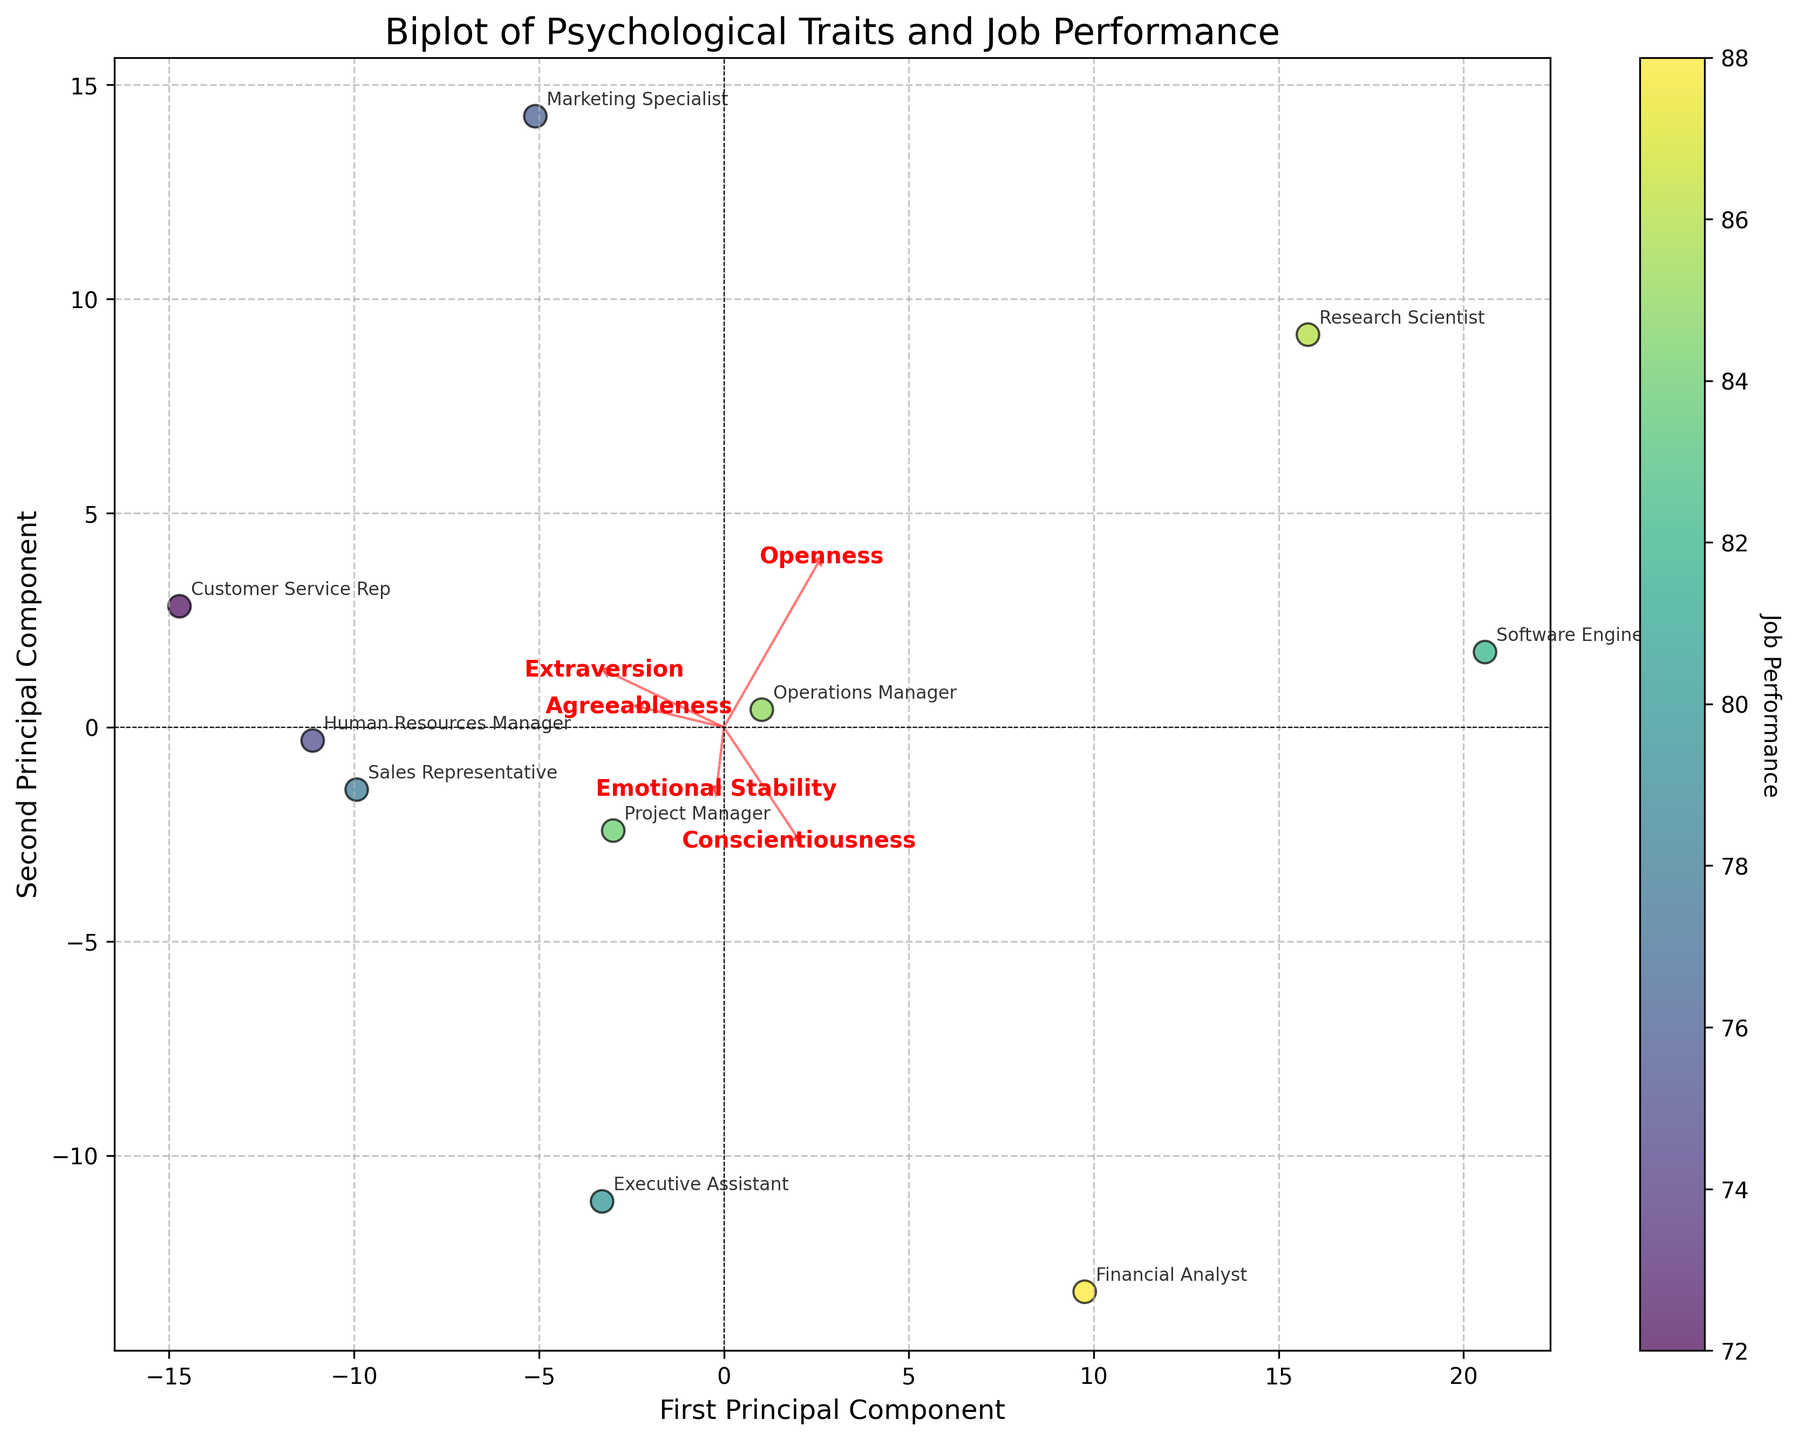Which job shows the highest job performance score? To find the job with the highest score, look for the data point that has the highest value in the colorbar.
Answer: Financial Analyst Which trait has the longest arrow in the biplot? To determine the trait with the longest arrow, compare the lengths of the arrows representing each trait. The trait with the arrow extending the furthest from the origin is Conscientiousness.
Answer: Conscientiousness Which trait is most closely associated with the first principal component? The trait most closely associated with the first principal component will have the arrow that is most aligned with the x-axis.
Answer: Conscientiousness Are traits Openness and Extraversion positively or negatively correlated? To determine the correlation between Openness and Extraversion, observe the direction of their arrows. If they point in similar directions, they are positively correlated. If they point in opposite directions, they are negatively correlated. Both arrows point towards the top-right, indicating positive correlation.
Answer: Positively What job role has the highest score on the second principal component? To find the job role with the highest score, locate the data point that is positioned furthest along the y-axis.
Answer: Research Scientist Which job roles show a relatively high level of Emotional Stability? To identify which job roles have high Emotional Stability, observe the positions of data points along the direction of the Emotional Stability arrow. Jobs that are further in that direction have higher Emotional Stability. Both Operations Manager and Financial Analyst are positioned in that direction.
Answer: Operations Manager, Financial Analyst Which two traits appear to be least correlated with each other? To find the least correlated traits, look for arrows that are nearly perpendicular to each other. Agreeableness and Openness arrows are almost perpendicular.
Answer: Agreeableness and Openness How is the job performance of Executive Assistant visually represented? Locate the data point labeled 'Executive Assistant' and observe its color and position relative to the colorbar. It lies at a higher end with a score of around 80.
Answer: 80 Which trait does the Marketing Specialist align most closely with? Locate the 'Marketing Specialist' point and see which trait's arrow it is closest to. It is very close to the Extraversion arrow.
Answer: Extraversion What can be inferred about the relationship between Conscientiousness and Job Performance? Observe how the data points are spread along the Conscientiousness arrow and their color. Job roles with higher Conscientiousness generally align with higher job performance colors.
Answer: Higher Conscientiousness generally aligns with higher job performance 